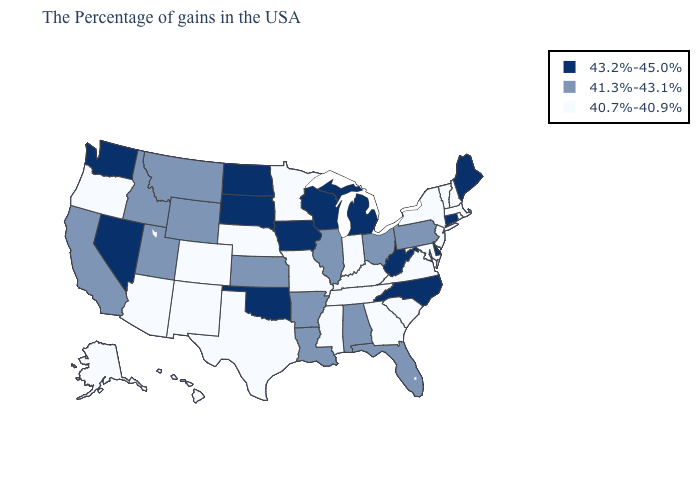Which states hav the highest value in the MidWest?
Quick response, please. Michigan, Wisconsin, Iowa, South Dakota, North Dakota. Which states have the lowest value in the USA?
Write a very short answer. Massachusetts, Rhode Island, New Hampshire, Vermont, New York, New Jersey, Maryland, Virginia, South Carolina, Georgia, Kentucky, Indiana, Tennessee, Mississippi, Missouri, Minnesota, Nebraska, Texas, Colorado, New Mexico, Arizona, Oregon, Alaska, Hawaii. What is the value of Wisconsin?
Write a very short answer. 43.2%-45.0%. Name the states that have a value in the range 43.2%-45.0%?
Keep it brief. Maine, Connecticut, Delaware, North Carolina, West Virginia, Michigan, Wisconsin, Iowa, Oklahoma, South Dakota, North Dakota, Nevada, Washington. Among the states that border New Mexico , does Arizona have the lowest value?
Write a very short answer. Yes. Among the states that border Georgia , does Alabama have the highest value?
Quick response, please. No. What is the highest value in states that border South Carolina?
Answer briefly. 43.2%-45.0%. What is the lowest value in the USA?
Write a very short answer. 40.7%-40.9%. What is the value of Arkansas?
Give a very brief answer. 41.3%-43.1%. Among the states that border Kansas , does Oklahoma have the highest value?
Quick response, please. Yes. What is the value of Nevada?
Be succinct. 43.2%-45.0%. Name the states that have a value in the range 43.2%-45.0%?
Answer briefly. Maine, Connecticut, Delaware, North Carolina, West Virginia, Michigan, Wisconsin, Iowa, Oklahoma, South Dakota, North Dakota, Nevada, Washington. Among the states that border New Jersey , which have the lowest value?
Keep it brief. New York. What is the highest value in states that border Maryland?
Short answer required. 43.2%-45.0%. Does Ohio have the lowest value in the USA?
Answer briefly. No. 